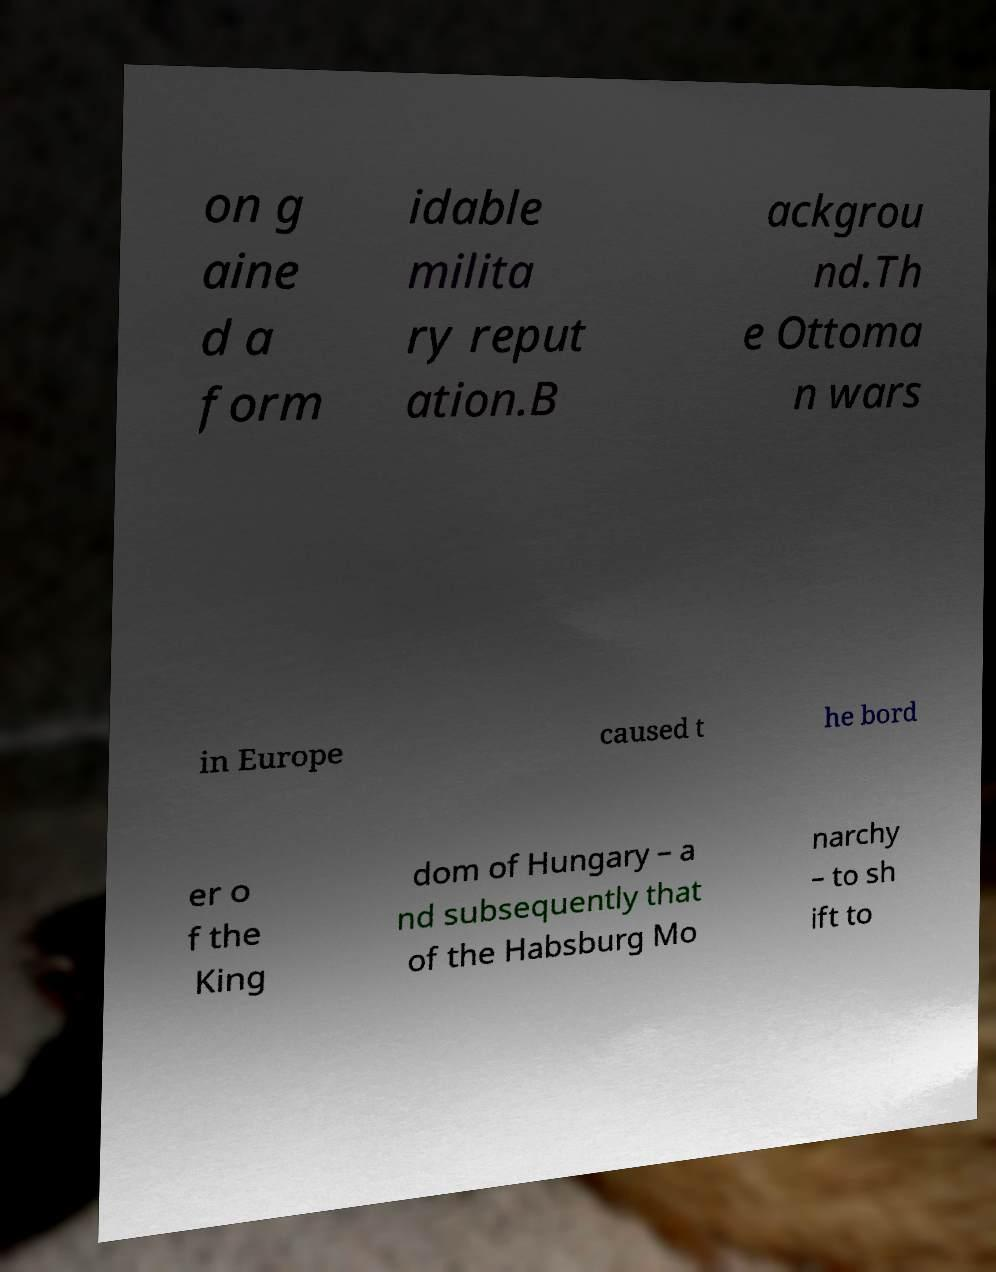Can you accurately transcribe the text from the provided image for me? on g aine d a form idable milita ry reput ation.B ackgrou nd.Th e Ottoma n wars in Europe caused t he bord er o f the King dom of Hungary – a nd subsequently that of the Habsburg Mo narchy – to sh ift to 